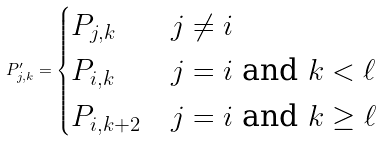Convert formula to latex. <formula><loc_0><loc_0><loc_500><loc_500>P ^ { \prime } _ { j , k } = \begin{cases} P _ { j , k } & j \neq i \\ P _ { i , k } & j = i \text { and } k < \ell \\ P _ { i , k + 2 } & j = i \text { and } k \geq \ell \end{cases}</formula> 